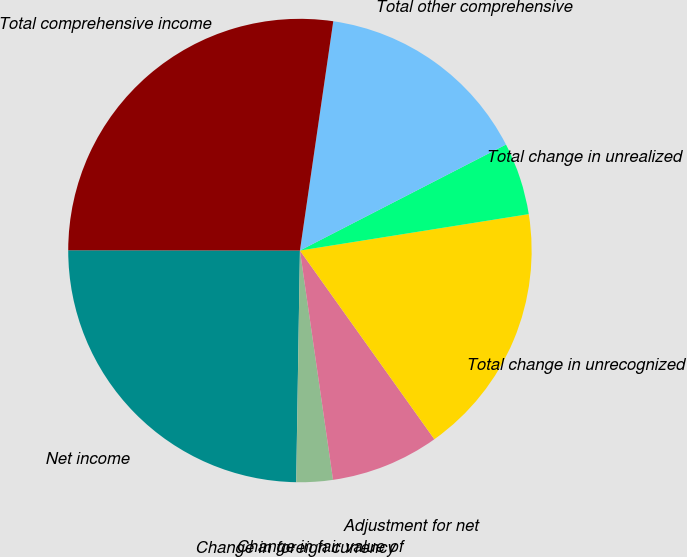Convert chart. <chart><loc_0><loc_0><loc_500><loc_500><pie_chart><fcel>Net income<fcel>Change in foreign currency<fcel>Change in fair value of<fcel>Adjustment for net<fcel>Total change in unrecognized<fcel>Total change in unrealized<fcel>Total other comprehensive<fcel>Total comprehensive income<nl><fcel>24.76%<fcel>0.01%<fcel>2.53%<fcel>7.57%<fcel>17.66%<fcel>5.05%<fcel>15.14%<fcel>27.28%<nl></chart> 